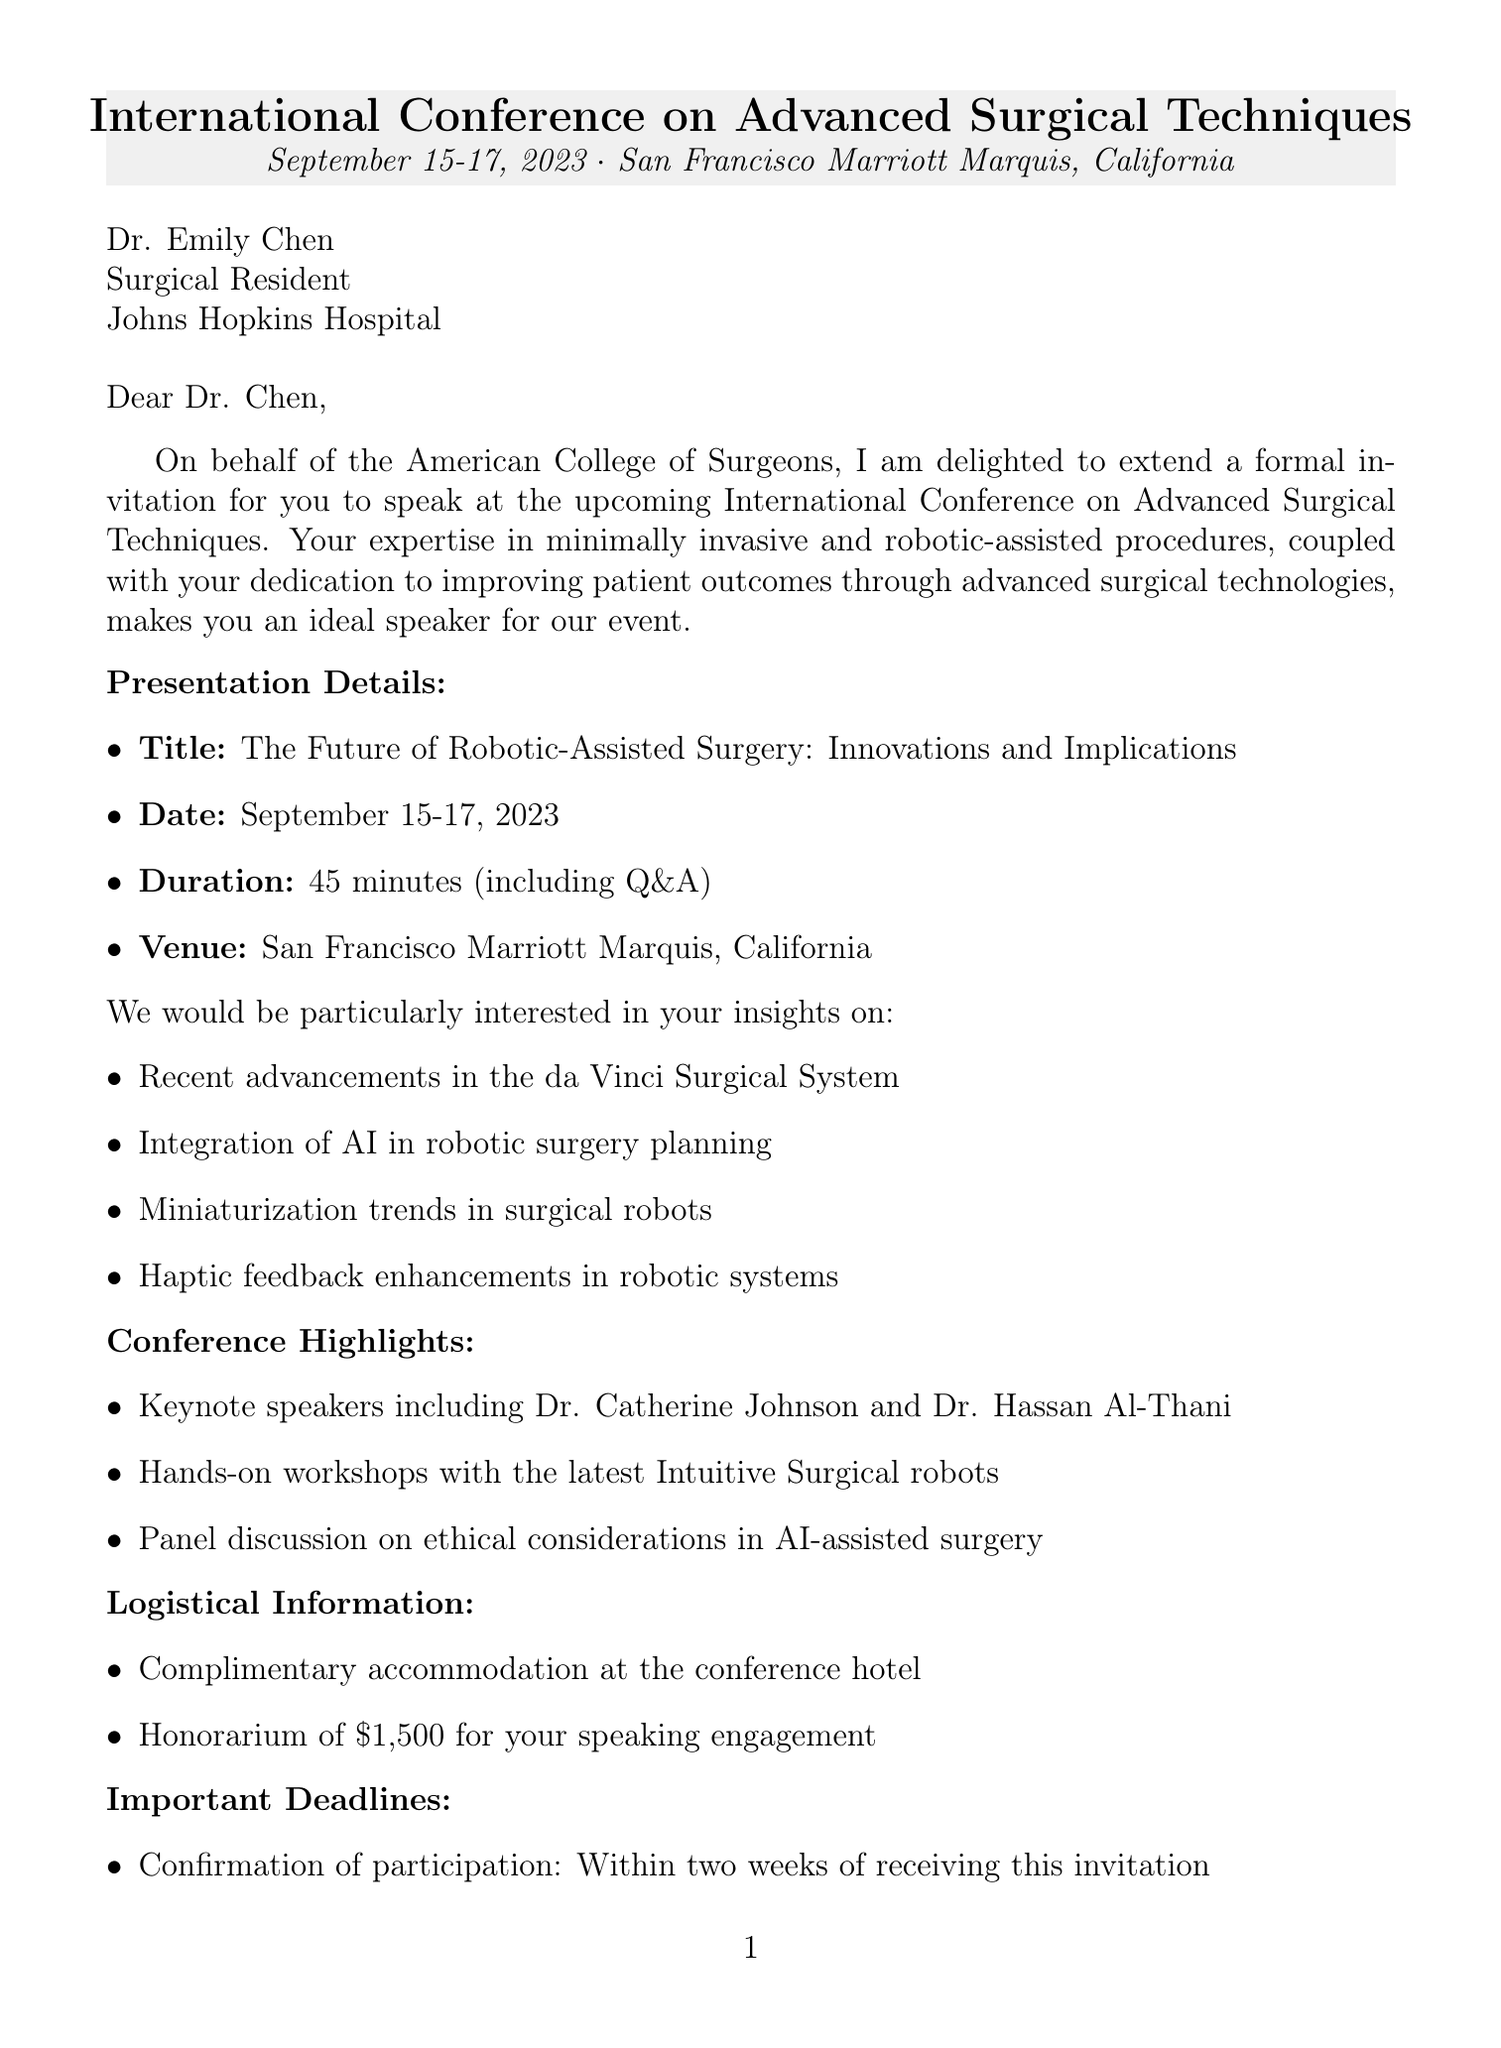What are the dates of the conference? The document states that the conference will be held on September 15-17, 2023.
Answer: September 15-17, 2023 Who is the invited speaker? The letter mentions Dr. Emily Chen as the invited speaker for the conference.
Answer: Dr. Emily Chen What is the honorarium for the speaking engagement? The document specifies the honorarium amount offered for the speaking engagement, which is $1,500.
Answer: $1,500 What is the main topic of the presentation? The presentation title is provided in the document, which focuses on robotic-assisted surgery innovations and implications.
Answer: The Future of Robotic-Assisted Surgery: Innovations and Implications What is the deadline for abstract submission? The letter indicates that the deadline for submitting the abstract is July 1, 2023.
Answer: July 1, 2023 How long is the presentation duration? The document states that the presentation will last for 45 minutes, including Q&A.
Answer: 45 minutes What is the name of the conference organizer? The organizer of the conference is mentioned in the document.
Answer: American College of Surgeons What opportunities does the conference offer for publication? The letter notes that there is an opportunity to publish an extended version of the presentation in a specific journal.
Answer: Journal of Robotic Surgery 